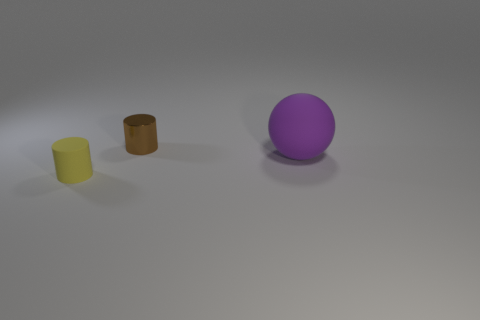How many things are matte things that are to the left of the large ball or small objects in front of the tiny shiny thing?
Offer a terse response. 1. What size is the cylinder in front of the matte object right of the small yellow cylinder?
Make the answer very short. Small. Do the rubber thing on the right side of the small brown metal thing and the tiny shiny object have the same color?
Your answer should be compact. No. Is there another red shiny object of the same shape as the large thing?
Provide a short and direct response. No. There is a cylinder that is the same size as the brown metallic thing; what is its color?
Make the answer very short. Yellow. How big is the rubber object behind the yellow rubber cylinder?
Offer a terse response. Large. Is there a cylinder that is in front of the small cylinder that is in front of the big purple ball?
Your response must be concise. No. Are the cylinder in front of the large purple sphere and the big object made of the same material?
Provide a succinct answer. Yes. What number of objects are both on the left side of the small brown cylinder and to the right of the tiny shiny object?
Give a very brief answer. 0. How many other objects are made of the same material as the tiny yellow thing?
Your response must be concise. 1. 